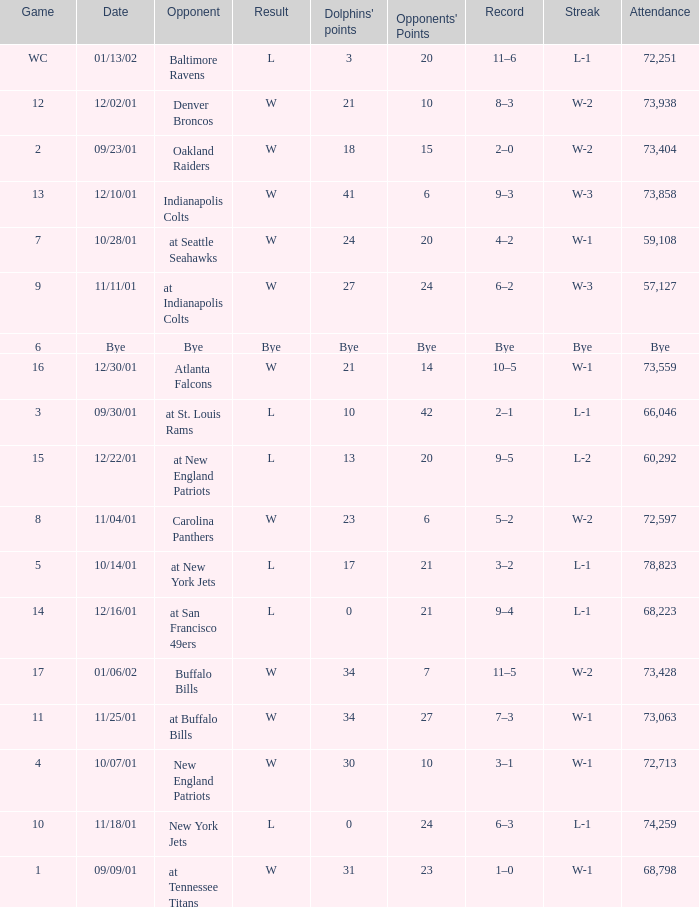How many opponents points were there on 11/11/01? 24.0. 